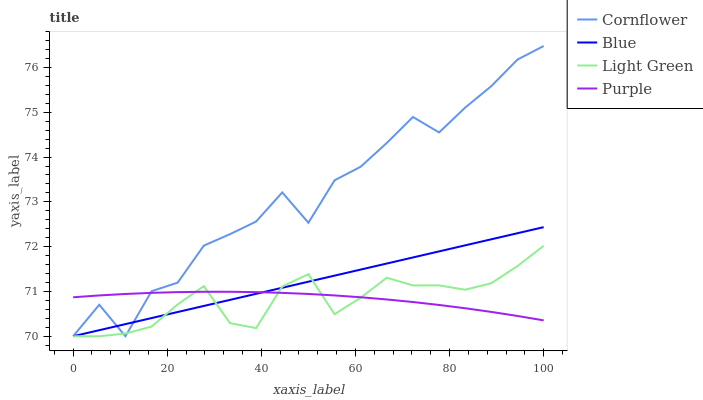Does Light Green have the minimum area under the curve?
Answer yes or no. Yes. Does Cornflower have the maximum area under the curve?
Answer yes or no. Yes. Does Purple have the minimum area under the curve?
Answer yes or no. No. Does Purple have the maximum area under the curve?
Answer yes or no. No. Is Blue the smoothest?
Answer yes or no. Yes. Is Cornflower the roughest?
Answer yes or no. Yes. Is Purple the smoothest?
Answer yes or no. No. Is Purple the roughest?
Answer yes or no. No. Does Blue have the lowest value?
Answer yes or no. Yes. Does Purple have the lowest value?
Answer yes or no. No. Does Cornflower have the highest value?
Answer yes or no. Yes. Does Purple have the highest value?
Answer yes or no. No. Does Cornflower intersect Blue?
Answer yes or no. Yes. Is Cornflower less than Blue?
Answer yes or no. No. Is Cornflower greater than Blue?
Answer yes or no. No. 